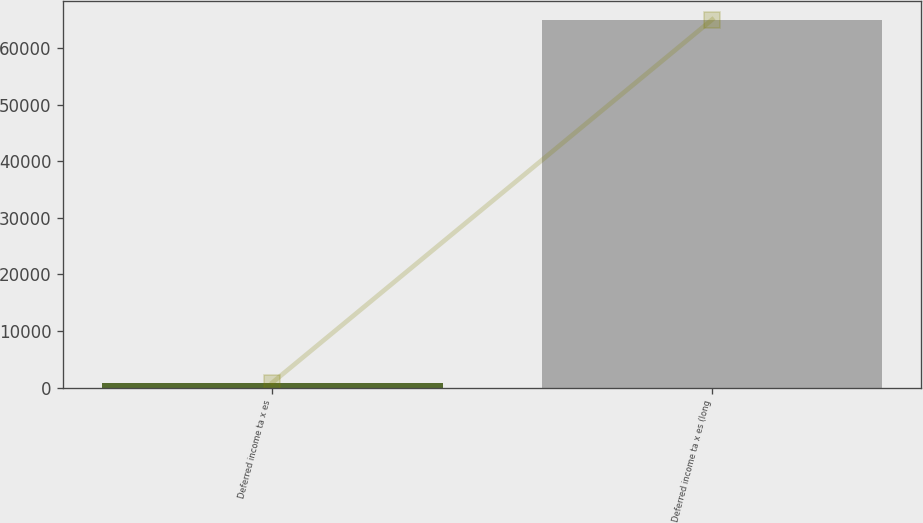<chart> <loc_0><loc_0><loc_500><loc_500><bar_chart><fcel>Deferred income ta x es<fcel>Deferred income ta x es (long<nl><fcel>882<fcel>65066<nl></chart> 